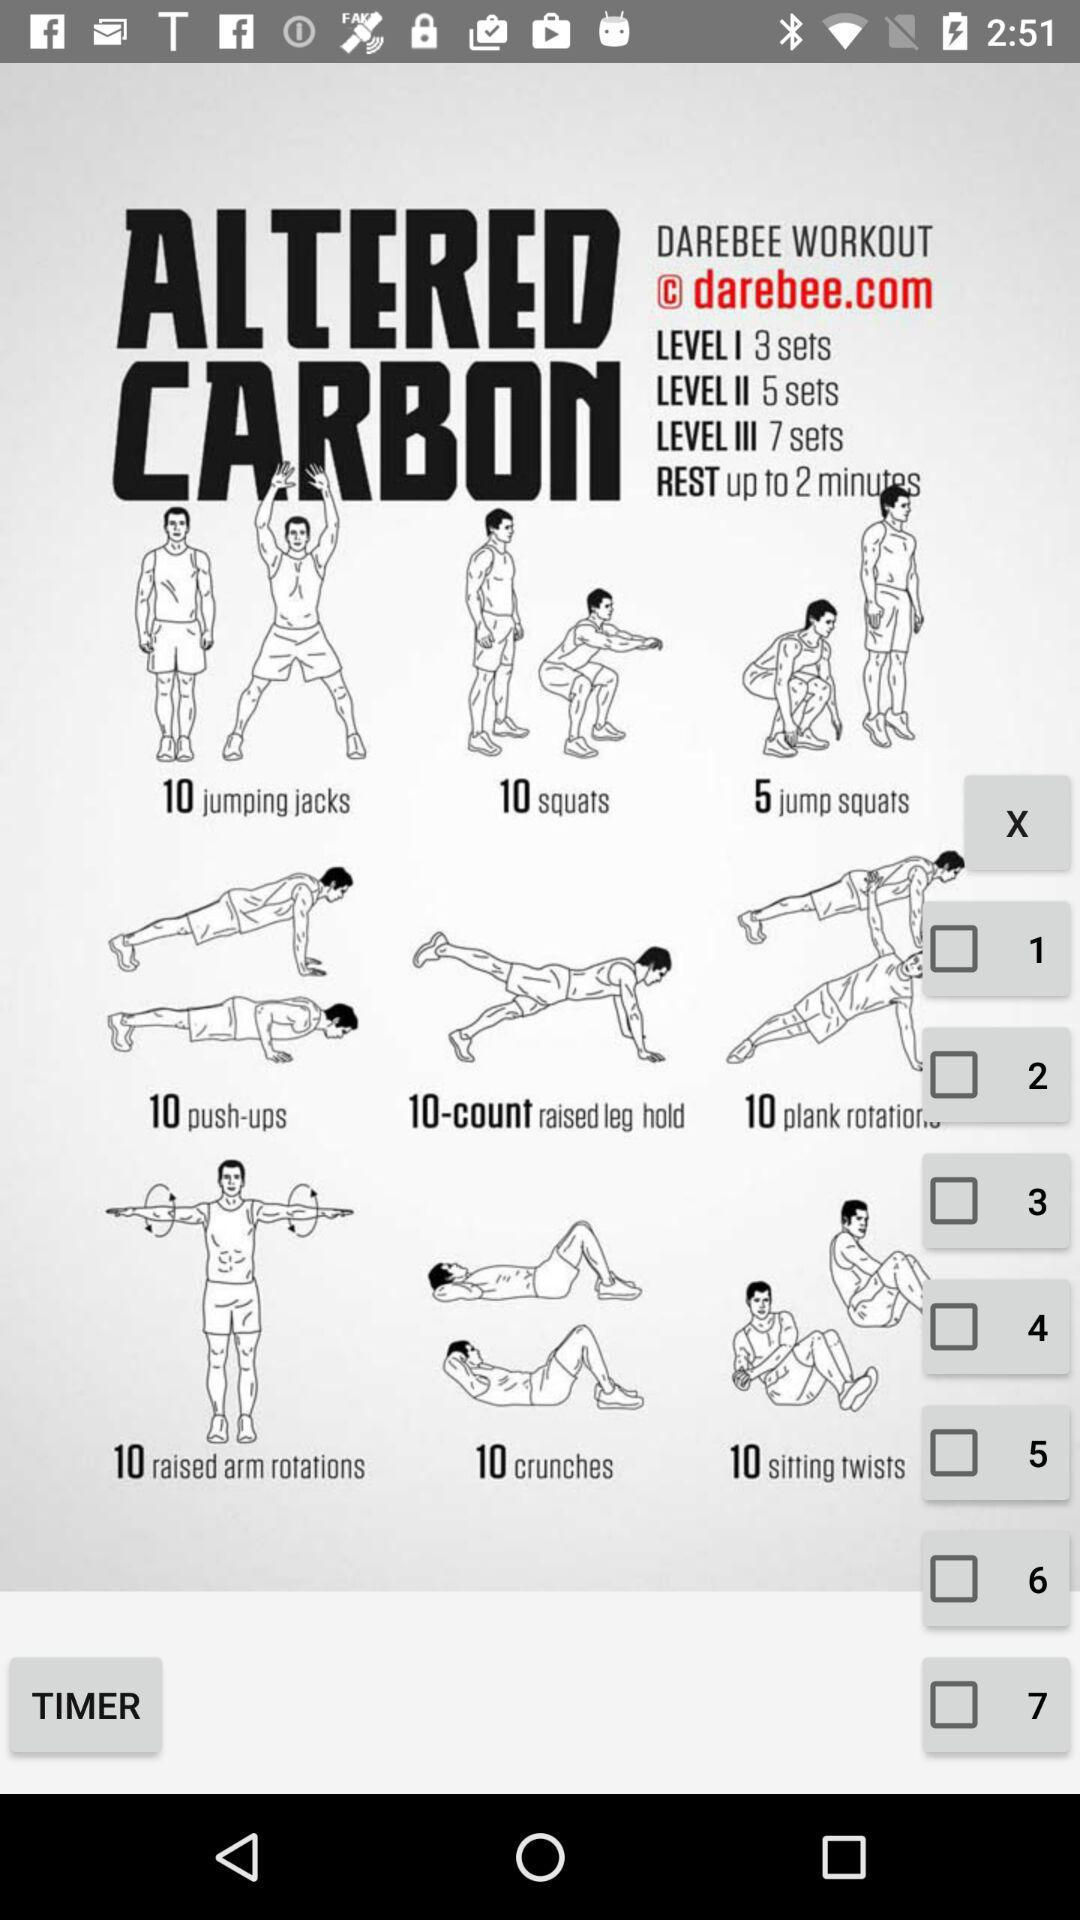How many sets are in level III?
Answer the question using a single word or phrase. 7 